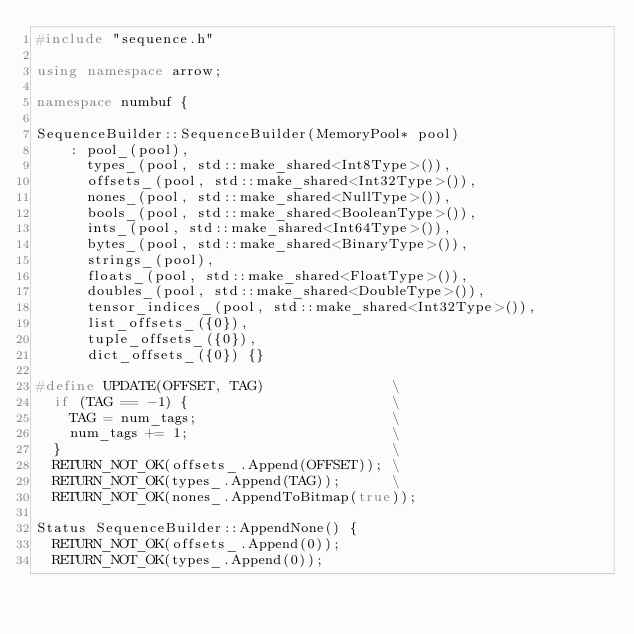<code> <loc_0><loc_0><loc_500><loc_500><_C++_>#include "sequence.h"

using namespace arrow;

namespace numbuf {

SequenceBuilder::SequenceBuilder(MemoryPool* pool)
    : pool_(pool),
      types_(pool, std::make_shared<Int8Type>()),
      offsets_(pool, std::make_shared<Int32Type>()),
      nones_(pool, std::make_shared<NullType>()),
      bools_(pool, std::make_shared<BooleanType>()),
      ints_(pool, std::make_shared<Int64Type>()),
      bytes_(pool, std::make_shared<BinaryType>()),
      strings_(pool),
      floats_(pool, std::make_shared<FloatType>()),
      doubles_(pool, std::make_shared<DoubleType>()),
      tensor_indices_(pool, std::make_shared<Int32Type>()),
      list_offsets_({0}),
      tuple_offsets_({0}),
      dict_offsets_({0}) {}

#define UPDATE(OFFSET, TAG)               \
  if (TAG == -1) {                        \
    TAG = num_tags;                       \
    num_tags += 1;                        \
  }                                       \
  RETURN_NOT_OK(offsets_.Append(OFFSET)); \
  RETURN_NOT_OK(types_.Append(TAG));      \
  RETURN_NOT_OK(nones_.AppendToBitmap(true));

Status SequenceBuilder::AppendNone() {
  RETURN_NOT_OK(offsets_.Append(0));
  RETURN_NOT_OK(types_.Append(0));</code> 